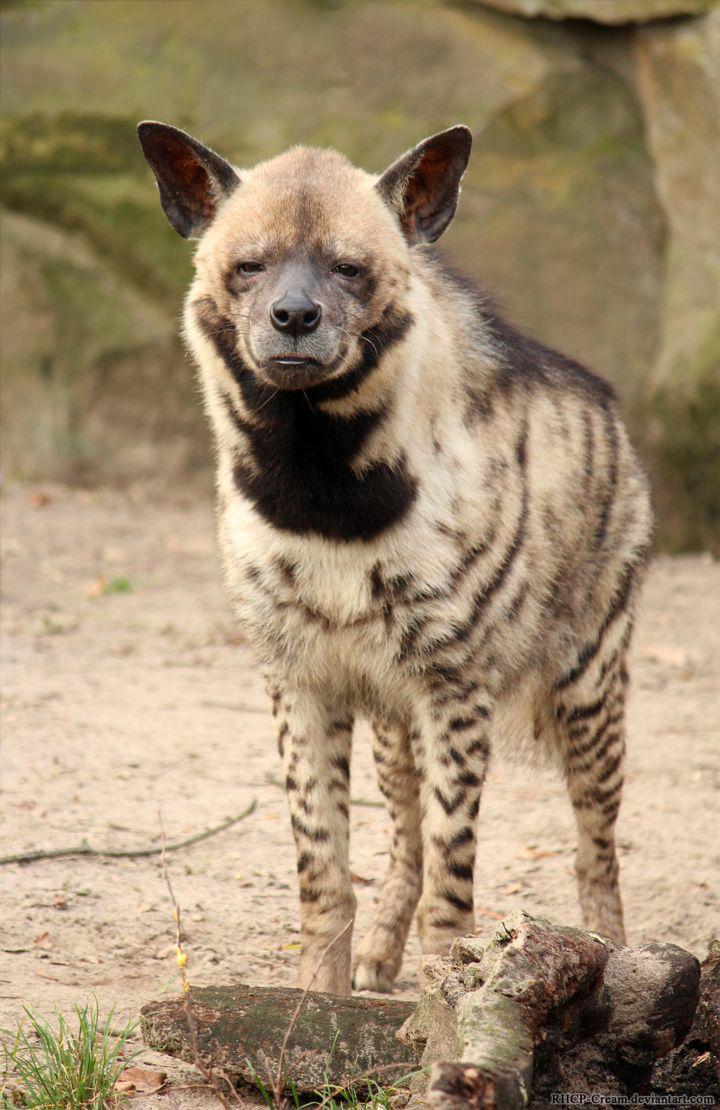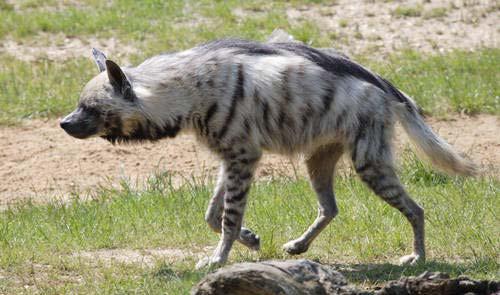The first image is the image on the left, the second image is the image on the right. Examine the images to the left and right. Is the description "The animal in one of the images has its body turned toward the camera." accurate? Answer yes or no. Yes. The first image is the image on the left, the second image is the image on the right. For the images displayed, is the sentence "An image shows only one hyena, with its head and body turned to the camera." factually correct? Answer yes or no. Yes. 